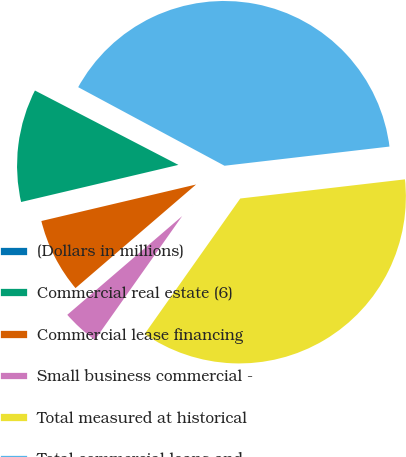Convert chart. <chart><loc_0><loc_0><loc_500><loc_500><pie_chart><fcel>(Dollars in millions)<fcel>Commercial real estate (6)<fcel>Commercial lease financing<fcel>Small business commercial -<fcel>Total measured at historical<fcel>Total commercial loans and<nl><fcel>0.23%<fcel>11.3%<fcel>7.61%<fcel>3.92%<fcel>36.62%<fcel>40.31%<nl></chart> 